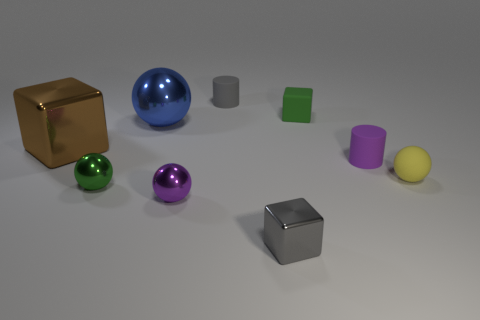Subtract all cyan balls. Subtract all green cylinders. How many balls are left? 4 Subtract all blocks. How many objects are left? 6 Subtract all rubber cubes. Subtract all large shiny objects. How many objects are left? 6 Add 7 green metallic objects. How many green metallic objects are left? 8 Add 5 tiny shiny cubes. How many tiny shiny cubes exist? 6 Subtract 0 cyan blocks. How many objects are left? 9 